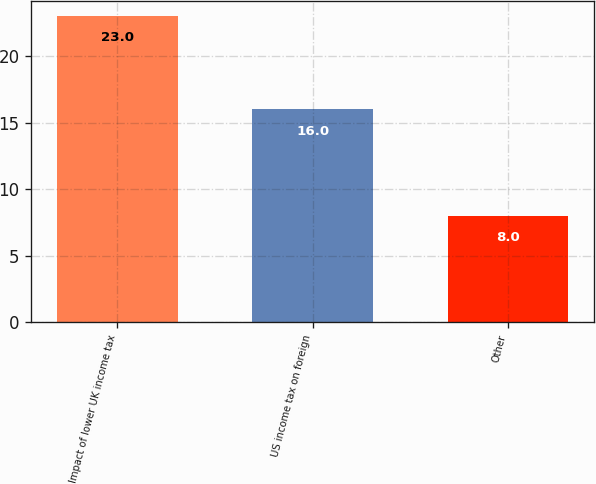Convert chart. <chart><loc_0><loc_0><loc_500><loc_500><bar_chart><fcel>Impact of lower UK income tax<fcel>US income tax on foreign<fcel>Other<nl><fcel>23<fcel>16<fcel>8<nl></chart> 